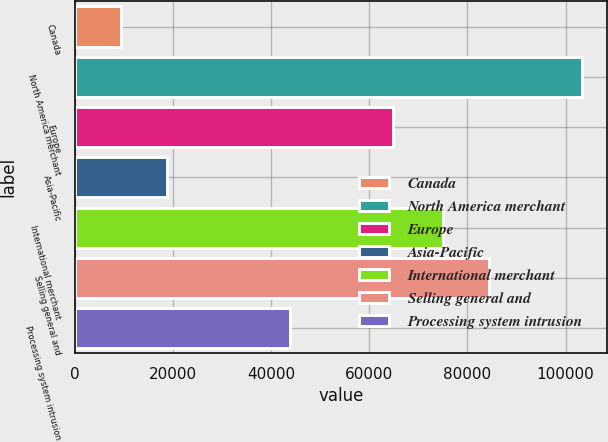Convert chart. <chart><loc_0><loc_0><loc_500><loc_500><bar_chart><fcel>Canada<fcel>North America merchant<fcel>Europe<fcel>Asia-Pacific<fcel>International merchant<fcel>Selling general and<fcel>Processing system intrusion<nl><fcel>9333<fcel>103317<fcel>64870<fcel>18731.4<fcel>74996<fcel>84394.4<fcel>43775<nl></chart> 